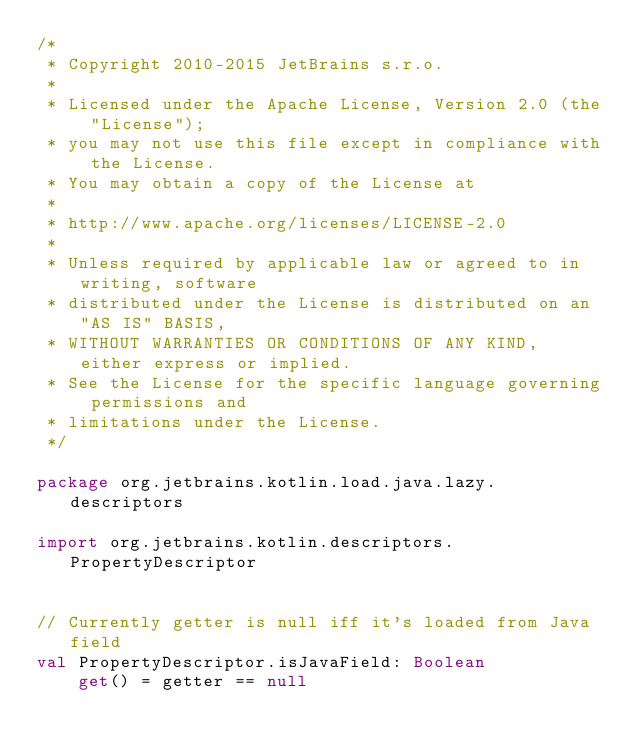<code> <loc_0><loc_0><loc_500><loc_500><_Kotlin_>/*
 * Copyright 2010-2015 JetBrains s.r.o.
 *
 * Licensed under the Apache License, Version 2.0 (the "License");
 * you may not use this file except in compliance with the License.
 * You may obtain a copy of the License at
 *
 * http://www.apache.org/licenses/LICENSE-2.0
 *
 * Unless required by applicable law or agreed to in writing, software
 * distributed under the License is distributed on an "AS IS" BASIS,
 * WITHOUT WARRANTIES OR CONDITIONS OF ANY KIND, either express or implied.
 * See the License for the specific language governing permissions and
 * limitations under the License.
 */

package org.jetbrains.kotlin.load.java.lazy.descriptors

import org.jetbrains.kotlin.descriptors.PropertyDescriptor


// Currently getter is null iff it's loaded from Java field
val PropertyDescriptor.isJavaField: Boolean
    get() = getter == null</code> 